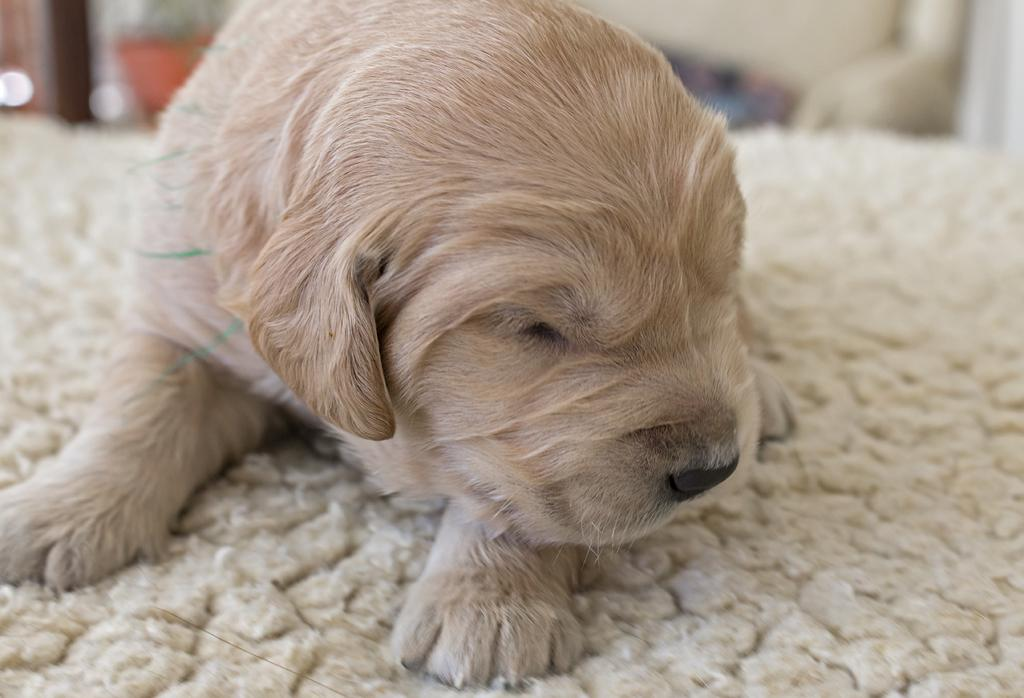What type of animal is present in the image? There is a dog in the image. What is the dog doing in the image? The dog is sleeping. On what surface is the dog resting? The dog is on a surface. What nighttime idea does the dog have in the image? There is no indication of the dog having any ideas, nighttime or otherwise, in the image. 